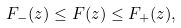Convert formula to latex. <formula><loc_0><loc_0><loc_500><loc_500>F _ { - } ( z ) \leq F ( z ) \leq F _ { + } ( z ) ,</formula> 